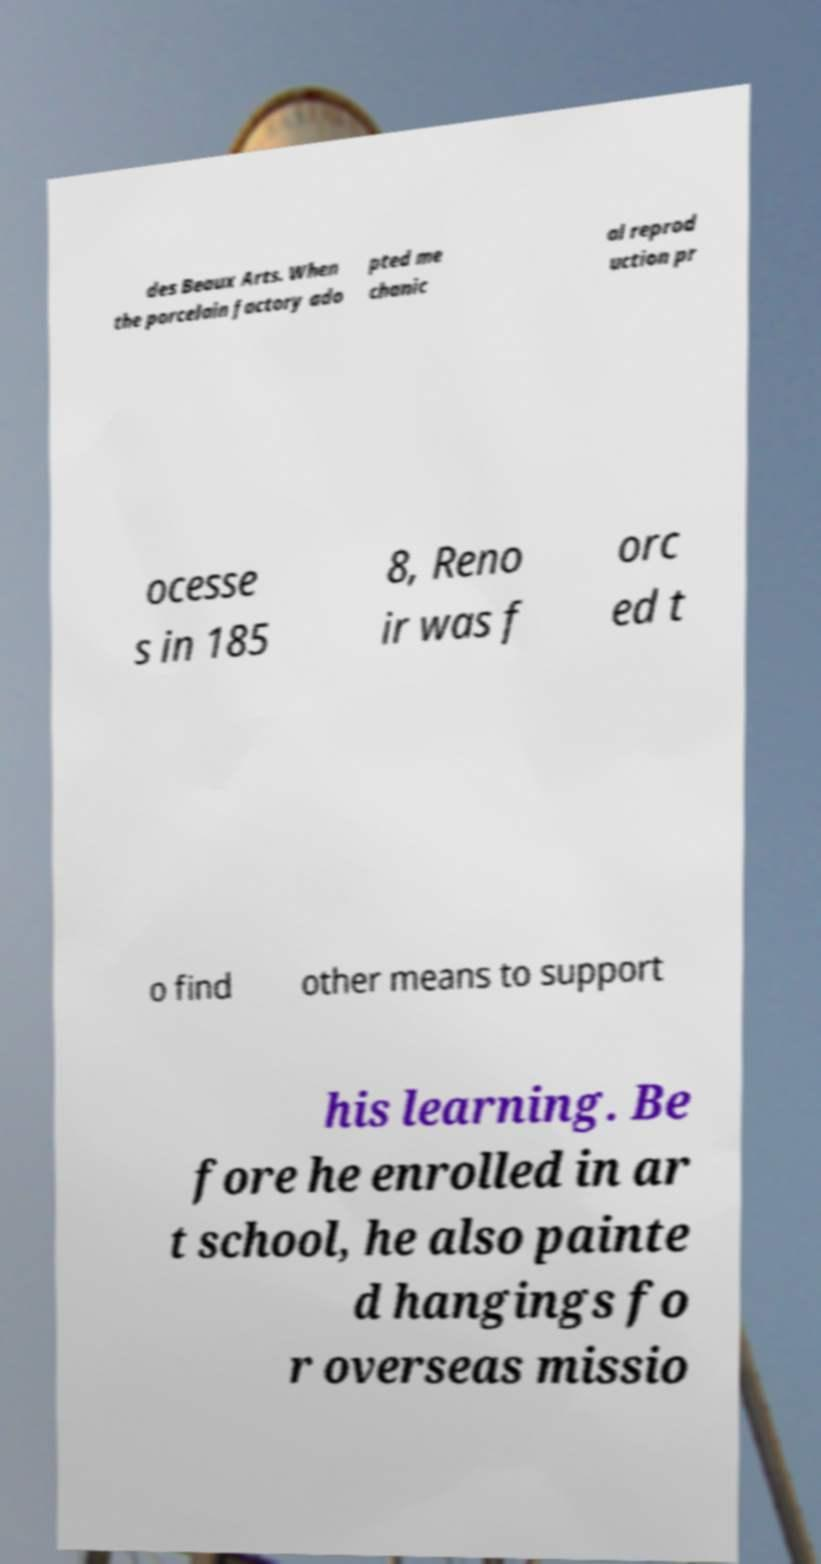What messages or text are displayed in this image? I need them in a readable, typed format. des Beaux Arts. When the porcelain factory ado pted me chanic al reprod uction pr ocesse s in 185 8, Reno ir was f orc ed t o find other means to support his learning. Be fore he enrolled in ar t school, he also painte d hangings fo r overseas missio 